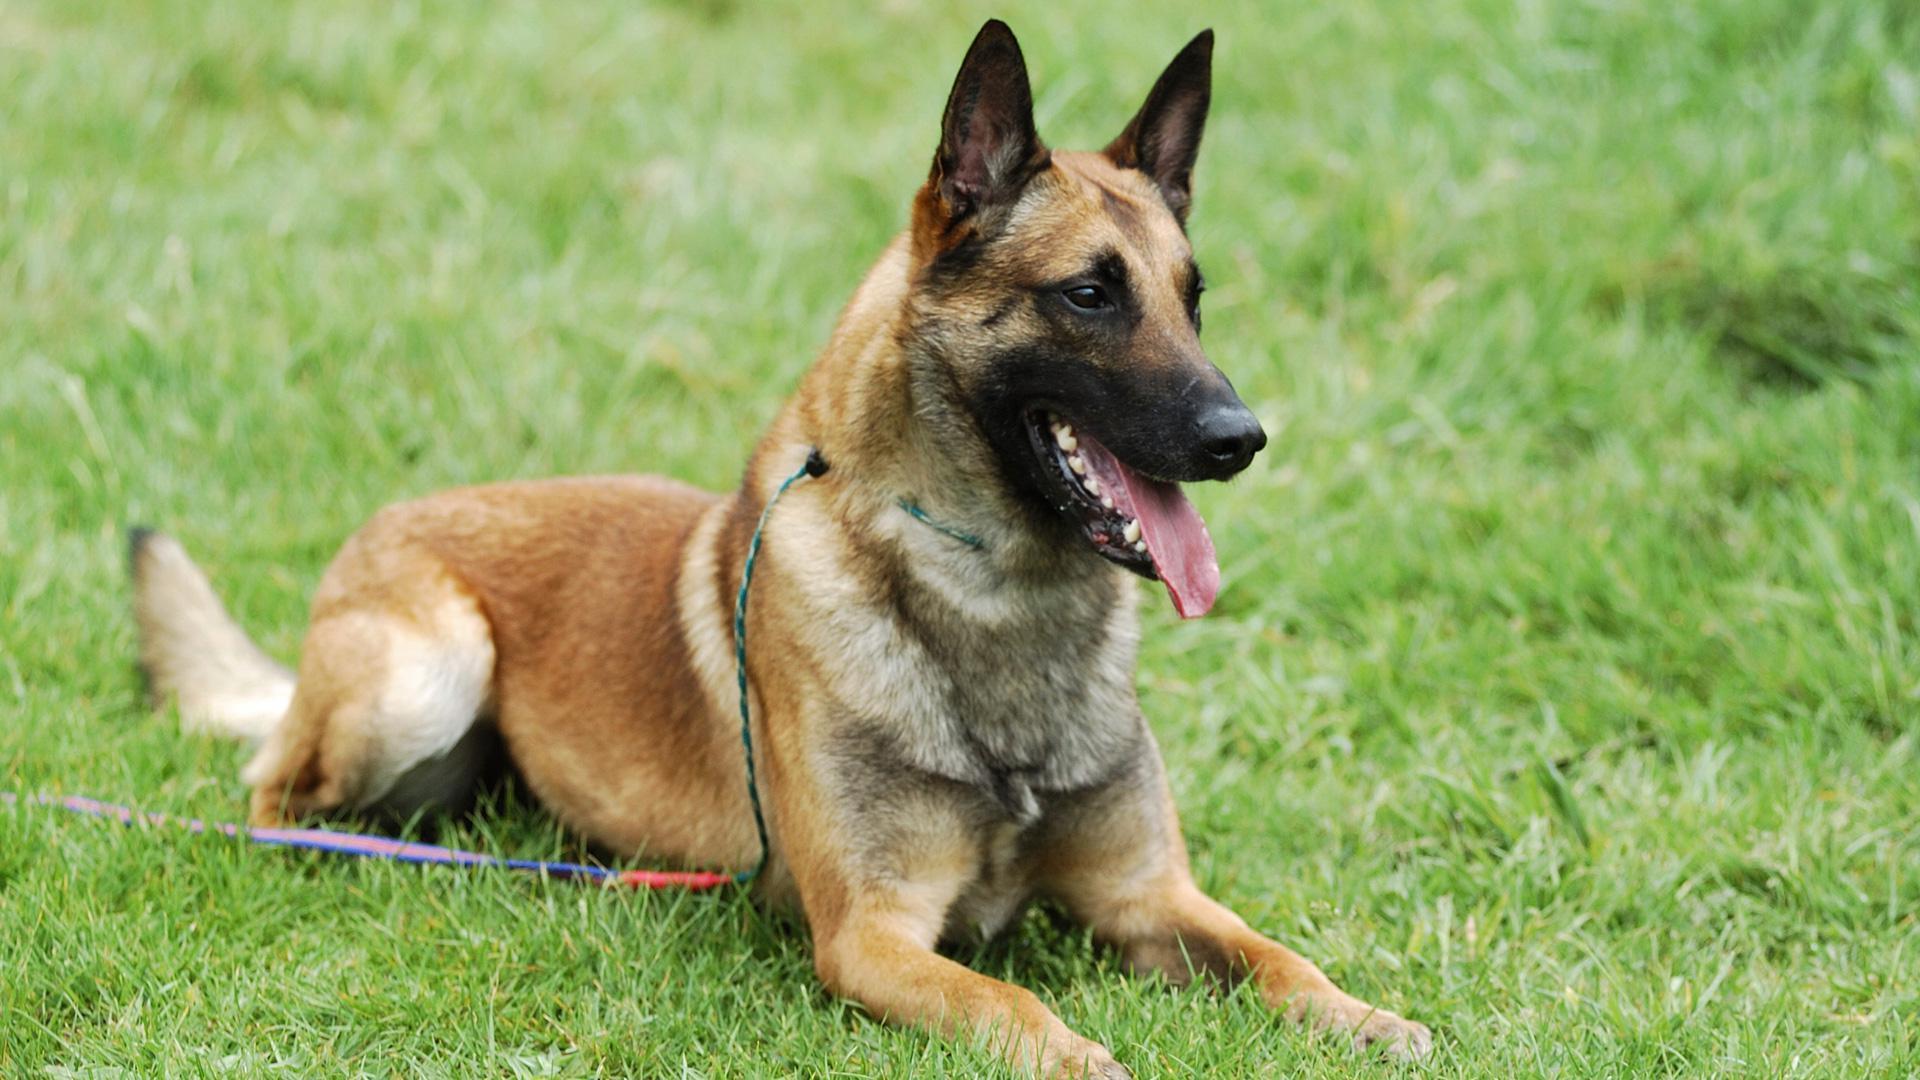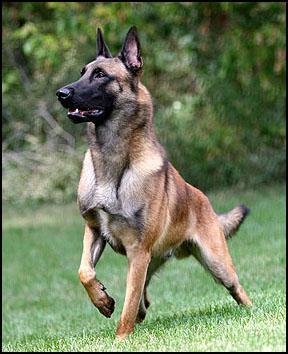The first image is the image on the left, the second image is the image on the right. For the images shown, is this caption "One german shepherd is standing and the other german shepherd is posed with its front paws extended; at least one dog wears a collar and leash but no dog wears a muzzle." true? Answer yes or no. Yes. 